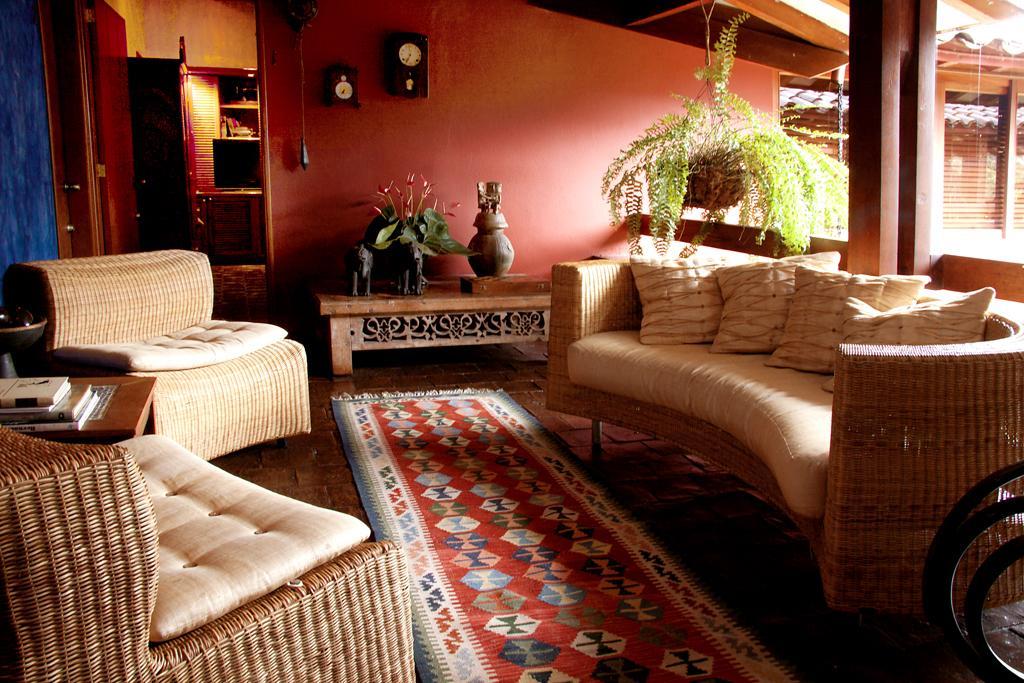Could you give a brief overview of what you see in this image? These are sofas,flower,on the wall there is click,here there are wheels, on table,these are books and these is door,this is carpet. 